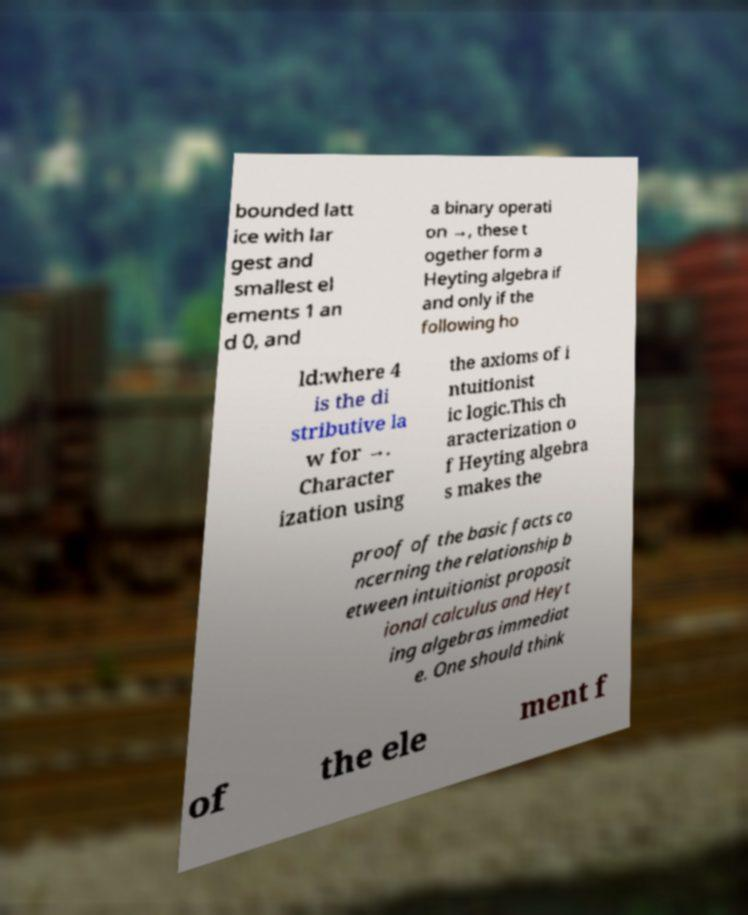Could you assist in decoding the text presented in this image and type it out clearly? bounded latt ice with lar gest and smallest el ements 1 an d 0, and a binary operati on →, these t ogether form a Heyting algebra if and only if the following ho ld:where 4 is the di stributive la w for →. Character ization using the axioms of i ntuitionist ic logic.This ch aracterization o f Heyting algebra s makes the proof of the basic facts co ncerning the relationship b etween intuitionist proposit ional calculus and Heyt ing algebras immediat e. One should think of the ele ment f 